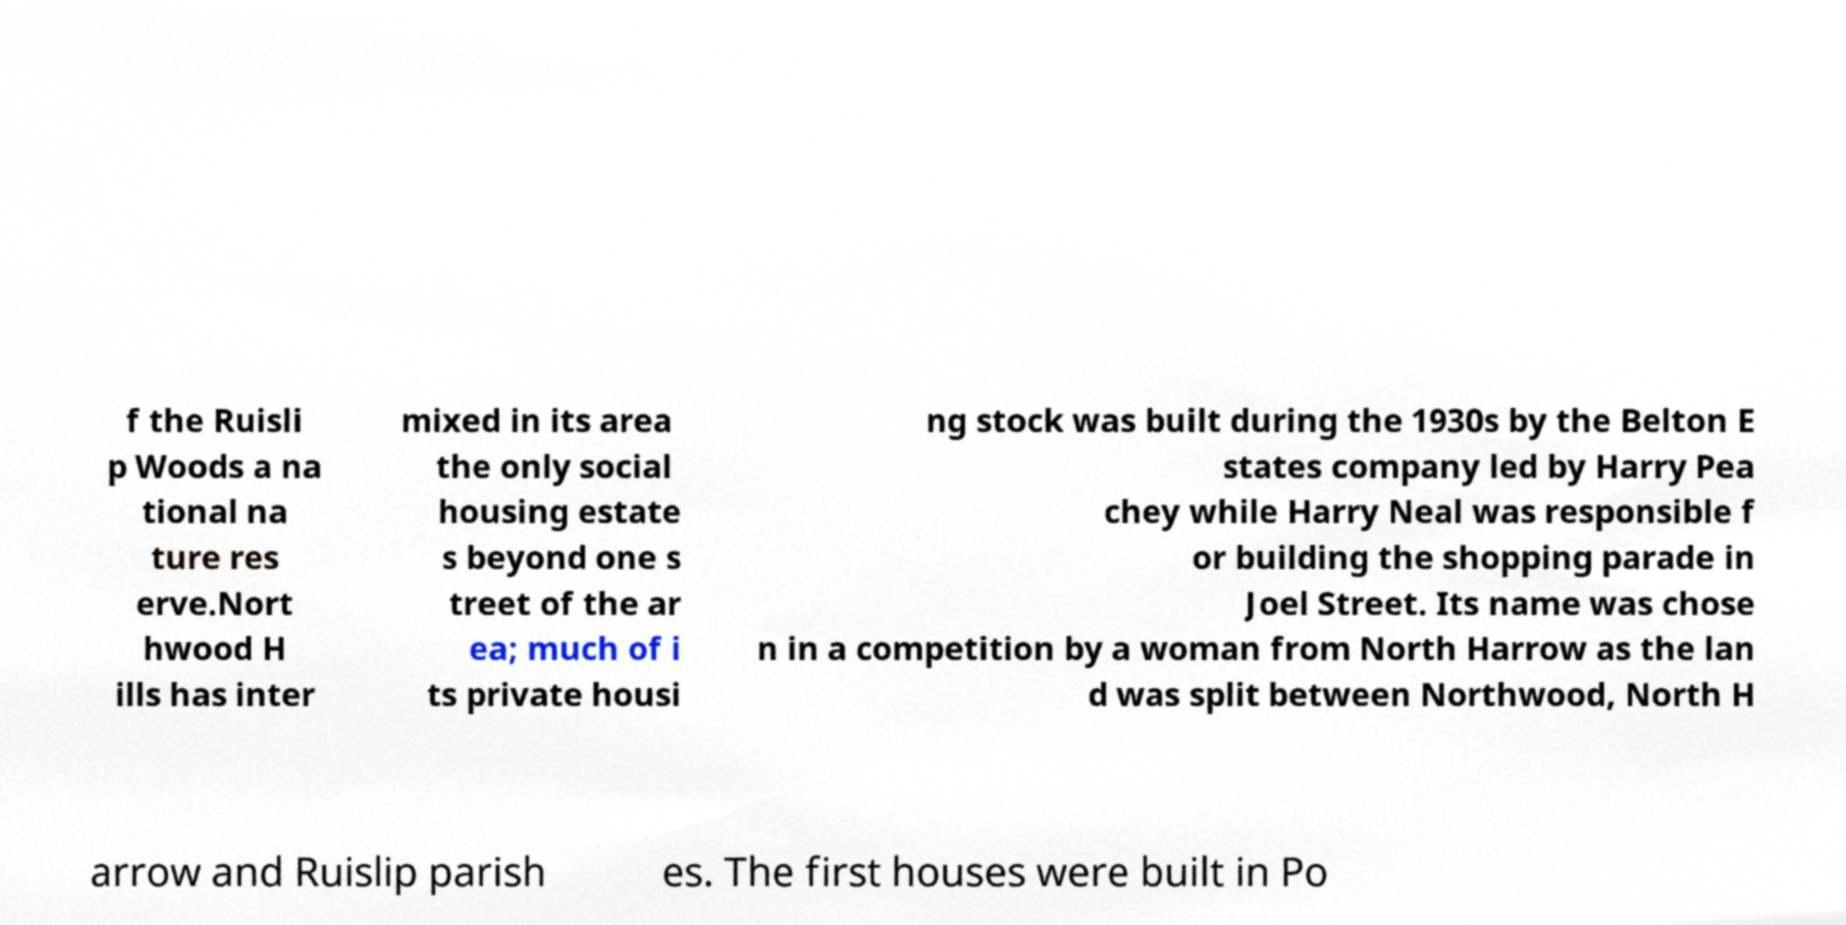I need the written content from this picture converted into text. Can you do that? f the Ruisli p Woods a na tional na ture res erve.Nort hwood H ills has inter mixed in its area the only social housing estate s beyond one s treet of the ar ea; much of i ts private housi ng stock was built during the 1930s by the Belton E states company led by Harry Pea chey while Harry Neal was responsible f or building the shopping parade in Joel Street. Its name was chose n in a competition by a woman from North Harrow as the lan d was split between Northwood, North H arrow and Ruislip parish es. The first houses were built in Po 